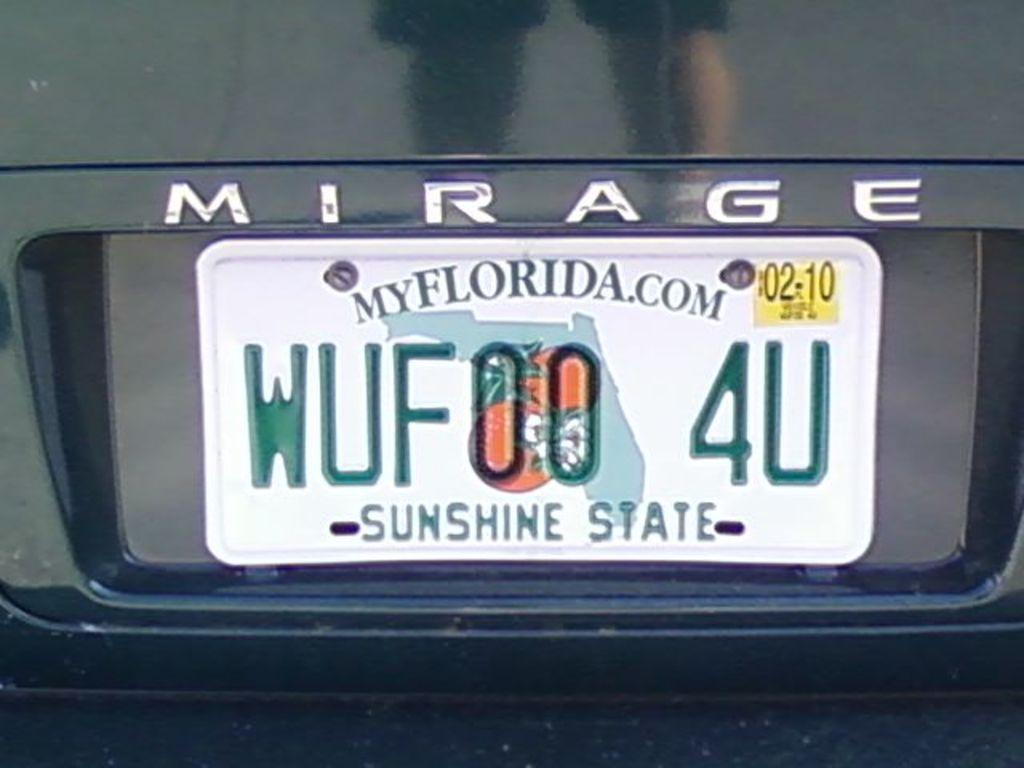<image>
Create a compact narrative representing the image presented. A Mirage vehicle with a Florida license plate. 